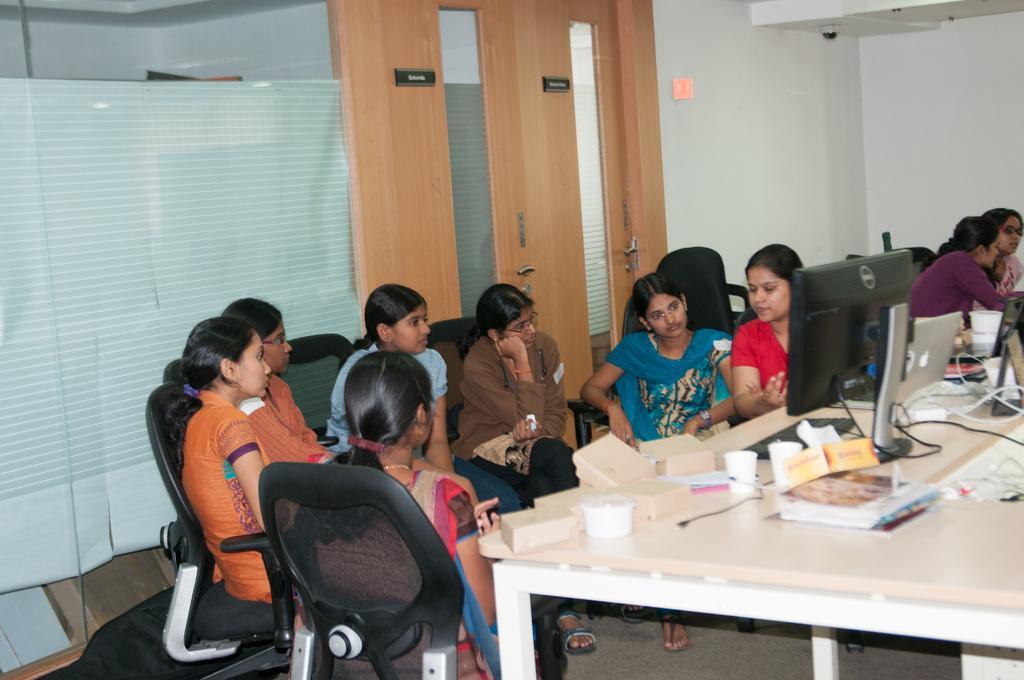Could you give a brief overview of what you see in this image? In the center we can see few women were sitting. In front of them we can see the table,on table we can see monitor,glass,book etc. Coming to the right corner we can see two more women were sitting. And coming to the background we can see door,wall and glass. 